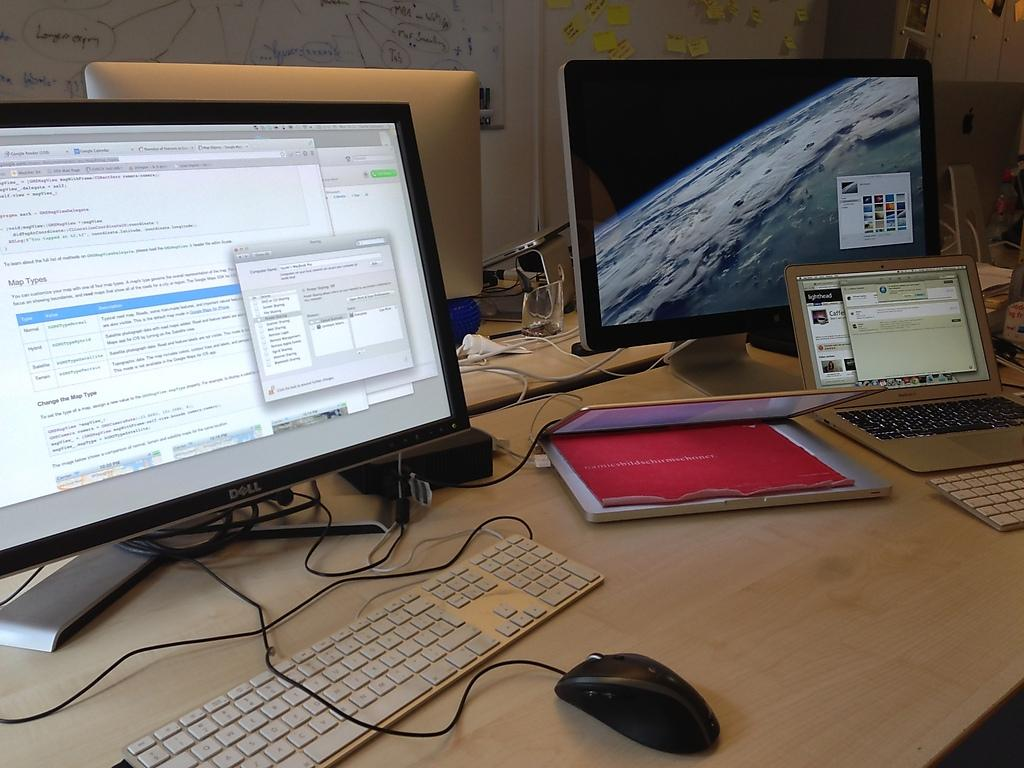Provide a one-sentence caption for the provided image. Two laptops sit on a desk next to a Dell monitor and another monitor. 